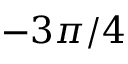Convert formula to latex. <formula><loc_0><loc_0><loc_500><loc_500>- 3 \pi / 4</formula> 